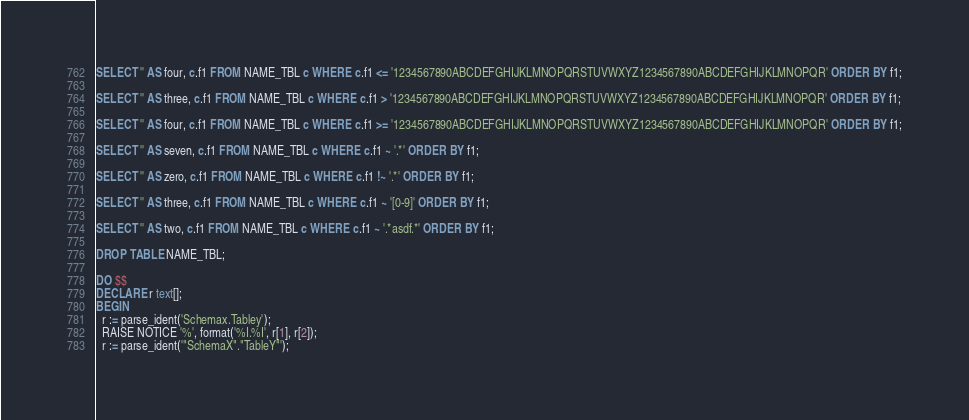<code> <loc_0><loc_0><loc_500><loc_500><_SQL_>SELECT '' AS four, c.f1 FROM NAME_TBL c WHERE c.f1 <= '1234567890ABCDEFGHIJKLMNOPQRSTUVWXYZ1234567890ABCDEFGHIJKLMNOPQR' ORDER BY f1;

SELECT '' AS three, c.f1 FROM NAME_TBL c WHERE c.f1 > '1234567890ABCDEFGHIJKLMNOPQRSTUVWXYZ1234567890ABCDEFGHIJKLMNOPQR' ORDER BY f1;

SELECT '' AS four, c.f1 FROM NAME_TBL c WHERE c.f1 >= '1234567890ABCDEFGHIJKLMNOPQRSTUVWXYZ1234567890ABCDEFGHIJKLMNOPQR' ORDER BY f1;

SELECT '' AS seven, c.f1 FROM NAME_TBL c WHERE c.f1 ~ '.*' ORDER BY f1;

SELECT '' AS zero, c.f1 FROM NAME_TBL c WHERE c.f1 !~ '.*' ORDER BY f1;

SELECT '' AS three, c.f1 FROM NAME_TBL c WHERE c.f1 ~ '[0-9]' ORDER BY f1;

SELECT '' AS two, c.f1 FROM NAME_TBL c WHERE c.f1 ~ '.*asdf.*' ORDER BY f1;

DROP TABLE NAME_TBL;

DO $$
DECLARE r text[];
BEGIN
  r := parse_ident('Schemax.Tabley');
  RAISE NOTICE '%', format('%I.%I', r[1], r[2]);
  r := parse_ident('"SchemaX"."TableY"');</code> 